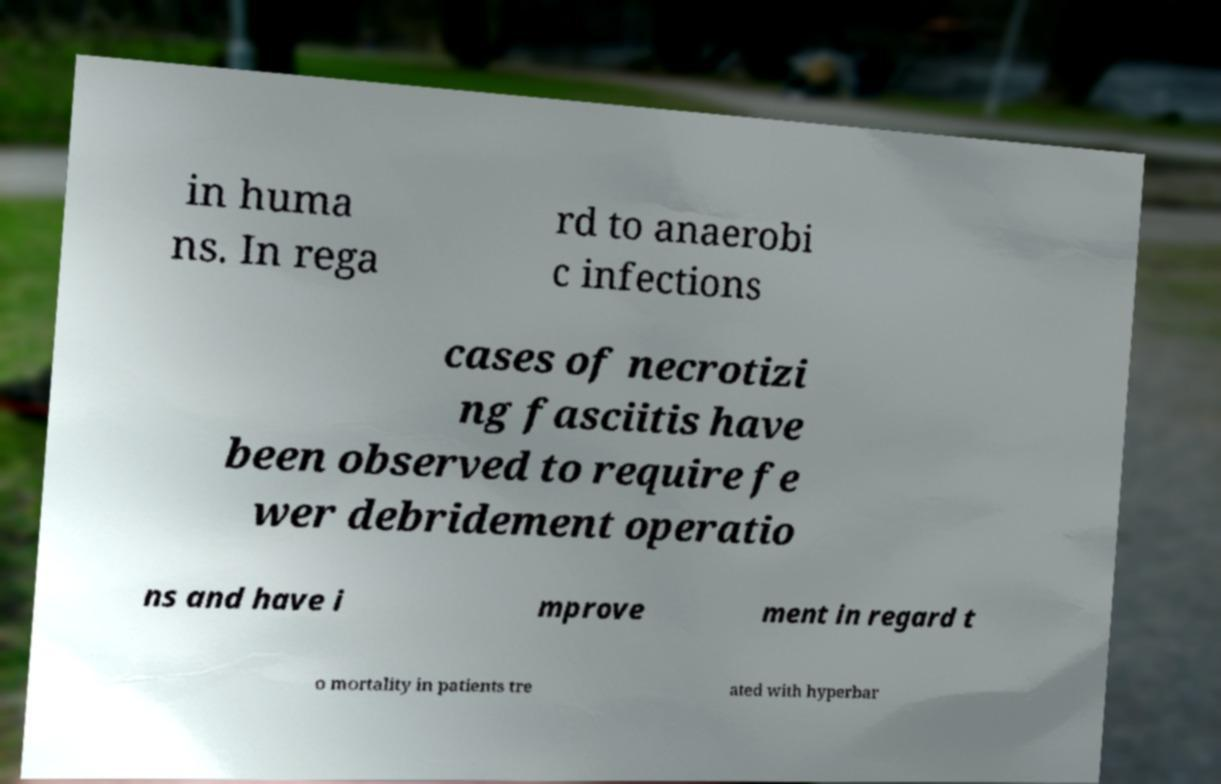There's text embedded in this image that I need extracted. Can you transcribe it verbatim? in huma ns. In rega rd to anaerobi c infections cases of necrotizi ng fasciitis have been observed to require fe wer debridement operatio ns and have i mprove ment in regard t o mortality in patients tre ated with hyperbar 